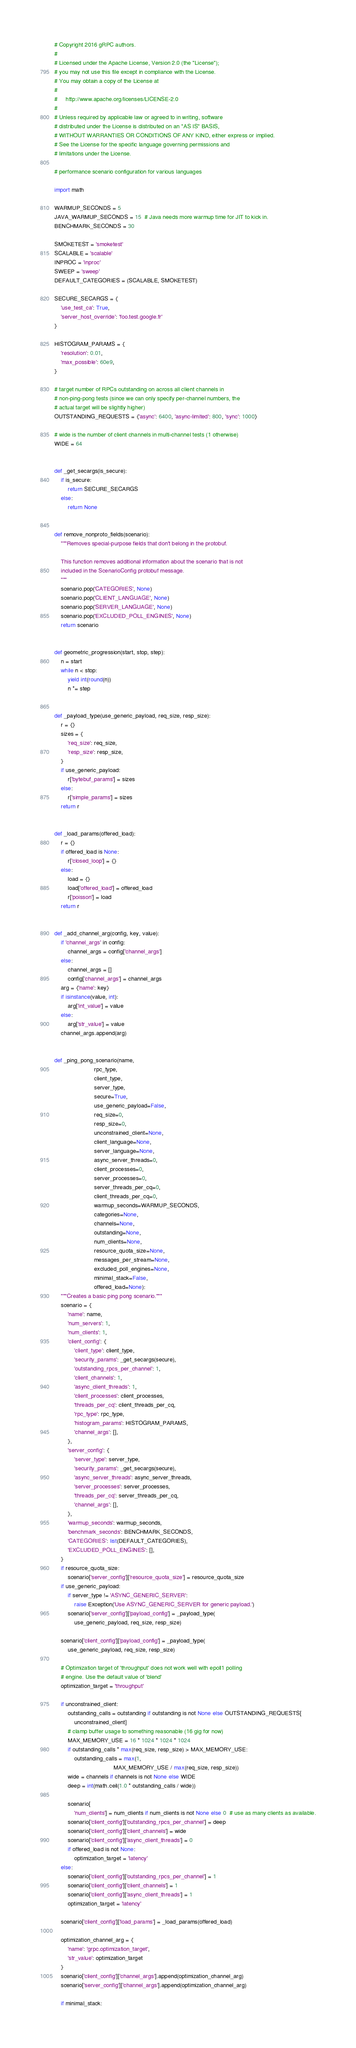<code> <loc_0><loc_0><loc_500><loc_500><_Python_># Copyright 2016 gRPC authors.
#
# Licensed under the Apache License, Version 2.0 (the "License");
# you may not use this file except in compliance with the License.
# You may obtain a copy of the License at
#
#     http://www.apache.org/licenses/LICENSE-2.0
#
# Unless required by applicable law or agreed to in writing, software
# distributed under the License is distributed on an "AS IS" BASIS,
# WITHOUT WARRANTIES OR CONDITIONS OF ANY KIND, either express or implied.
# See the License for the specific language governing permissions and
# limitations under the License.

# performance scenario configuration for various languages

import math

WARMUP_SECONDS = 5
JAVA_WARMUP_SECONDS = 15  # Java needs more warmup time for JIT to kick in.
BENCHMARK_SECONDS = 30

SMOKETEST = 'smoketest'
SCALABLE = 'scalable'
INPROC = 'inproc'
SWEEP = 'sweep'
DEFAULT_CATEGORIES = (SCALABLE, SMOKETEST)

SECURE_SECARGS = {
    'use_test_ca': True,
    'server_host_override': 'foo.test.google.fr'
}

HISTOGRAM_PARAMS = {
    'resolution': 0.01,
    'max_possible': 60e9,
}

# target number of RPCs outstanding on across all client channels in
# non-ping-pong tests (since we can only specify per-channel numbers, the
# actual target will be slightly higher)
OUTSTANDING_REQUESTS = {'async': 6400, 'async-limited': 800, 'sync': 1000}

# wide is the number of client channels in multi-channel tests (1 otherwise)
WIDE = 64


def _get_secargs(is_secure):
    if is_secure:
        return SECURE_SECARGS
    else:
        return None


def remove_nonproto_fields(scenario):
    """Removes special-purpose fields that don't belong in the protobuf.

    This function removes additional information about the scenario that is not
    included in the ScenarioConfig protobuf message.
    """
    scenario.pop('CATEGORIES', None)
    scenario.pop('CLIENT_LANGUAGE', None)
    scenario.pop('SERVER_LANGUAGE', None)
    scenario.pop('EXCLUDED_POLL_ENGINES', None)
    return scenario


def geometric_progression(start, stop, step):
    n = start
    while n < stop:
        yield int(round(n))
        n *= step


def _payload_type(use_generic_payload, req_size, resp_size):
    r = {}
    sizes = {
        'req_size': req_size,
        'resp_size': resp_size,
    }
    if use_generic_payload:
        r['bytebuf_params'] = sizes
    else:
        r['simple_params'] = sizes
    return r


def _load_params(offered_load):
    r = {}
    if offered_load is None:
        r['closed_loop'] = {}
    else:
        load = {}
        load['offered_load'] = offered_load
        r['poisson'] = load
    return r


def _add_channel_arg(config, key, value):
    if 'channel_args' in config:
        channel_args = config['channel_args']
    else:
        channel_args = []
        config['channel_args'] = channel_args
    arg = {'name': key}
    if isinstance(value, int):
        arg['int_value'] = value
    else:
        arg['str_value'] = value
    channel_args.append(arg)


def _ping_pong_scenario(name,
                        rpc_type,
                        client_type,
                        server_type,
                        secure=True,
                        use_generic_payload=False,
                        req_size=0,
                        resp_size=0,
                        unconstrained_client=None,
                        client_language=None,
                        server_language=None,
                        async_server_threads=0,
                        client_processes=0,
                        server_processes=0,
                        server_threads_per_cq=0,
                        client_threads_per_cq=0,
                        warmup_seconds=WARMUP_SECONDS,
                        categories=None,
                        channels=None,
                        outstanding=None,
                        num_clients=None,
                        resource_quota_size=None,
                        messages_per_stream=None,
                        excluded_poll_engines=None,
                        minimal_stack=False,
                        offered_load=None):
    """Creates a basic ping pong scenario."""
    scenario = {
        'name': name,
        'num_servers': 1,
        'num_clients': 1,
        'client_config': {
            'client_type': client_type,
            'security_params': _get_secargs(secure),
            'outstanding_rpcs_per_channel': 1,
            'client_channels': 1,
            'async_client_threads': 1,
            'client_processes': client_processes,
            'threads_per_cq': client_threads_per_cq,
            'rpc_type': rpc_type,
            'histogram_params': HISTOGRAM_PARAMS,
            'channel_args': [],
        },
        'server_config': {
            'server_type': server_type,
            'security_params': _get_secargs(secure),
            'async_server_threads': async_server_threads,
            'server_processes': server_processes,
            'threads_per_cq': server_threads_per_cq,
            'channel_args': [],
        },
        'warmup_seconds': warmup_seconds,
        'benchmark_seconds': BENCHMARK_SECONDS,
        'CATEGORIES': list(DEFAULT_CATEGORIES),
        'EXCLUDED_POLL_ENGINES': [],
    }
    if resource_quota_size:
        scenario['server_config']['resource_quota_size'] = resource_quota_size
    if use_generic_payload:
        if server_type != 'ASYNC_GENERIC_SERVER':
            raise Exception('Use ASYNC_GENERIC_SERVER for generic payload.')
        scenario['server_config']['payload_config'] = _payload_type(
            use_generic_payload, req_size, resp_size)

    scenario['client_config']['payload_config'] = _payload_type(
        use_generic_payload, req_size, resp_size)

    # Optimization target of 'throughput' does not work well with epoll1 polling
    # engine. Use the default value of 'blend'
    optimization_target = 'throughput'

    if unconstrained_client:
        outstanding_calls = outstanding if outstanding is not None else OUTSTANDING_REQUESTS[
            unconstrained_client]
        # clamp buffer usage to something reasonable (16 gig for now)
        MAX_MEMORY_USE = 16 * 1024 * 1024 * 1024
        if outstanding_calls * max(req_size, resp_size) > MAX_MEMORY_USE:
            outstanding_calls = max(1,
                                    MAX_MEMORY_USE / max(req_size, resp_size))
        wide = channels if channels is not None else WIDE
        deep = int(math.ceil(1.0 * outstanding_calls / wide))

        scenario[
            'num_clients'] = num_clients if num_clients is not None else 0  # use as many clients as available.
        scenario['client_config']['outstanding_rpcs_per_channel'] = deep
        scenario['client_config']['client_channels'] = wide
        scenario['client_config']['async_client_threads'] = 0
        if offered_load is not None:
            optimization_target = 'latency'
    else:
        scenario['client_config']['outstanding_rpcs_per_channel'] = 1
        scenario['client_config']['client_channels'] = 1
        scenario['client_config']['async_client_threads'] = 1
        optimization_target = 'latency'

    scenario['client_config']['load_params'] = _load_params(offered_load)

    optimization_channel_arg = {
        'name': 'grpc.optimization_target',
        'str_value': optimization_target
    }
    scenario['client_config']['channel_args'].append(optimization_channel_arg)
    scenario['server_config']['channel_args'].append(optimization_channel_arg)

    if minimal_stack:</code> 